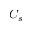<formula> <loc_0><loc_0><loc_500><loc_500>C _ { s }</formula> 